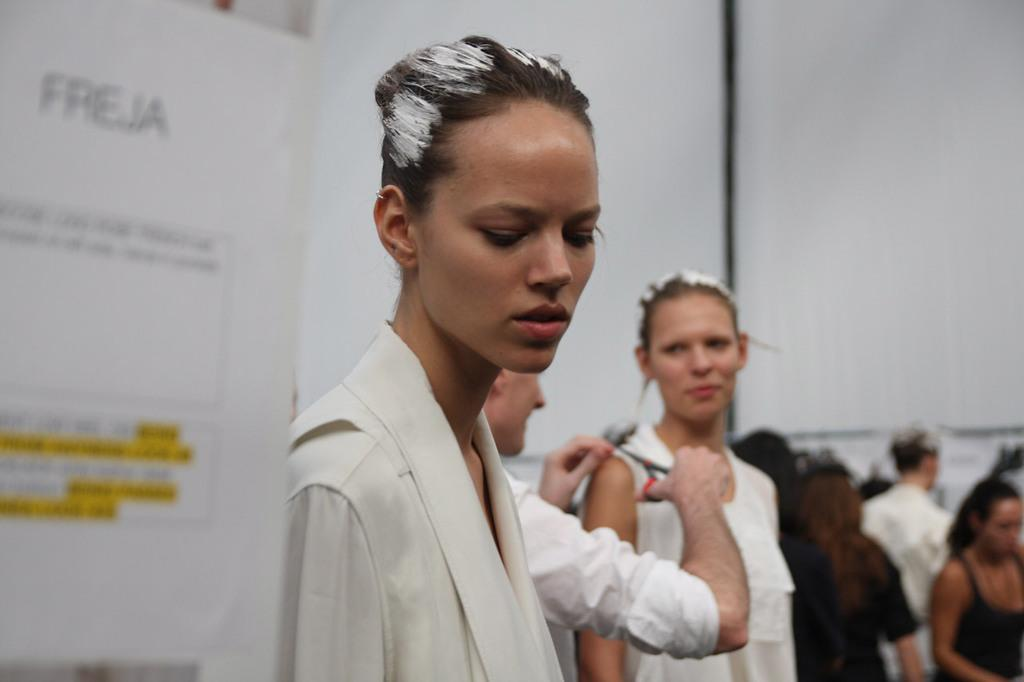What is the main subject of the image? The main subject of the image is a group of people. What colors are the people wearing? The people are wearing white and black color dresses. What can be seen to the left of the image? There is a banner to the left of the image. What color is the background of the image? The background of the image is white. Are there any swings visible in the image? No, there are no swings present in the image. What type of umbrella is being used by the people in the image? There is no umbrella visible in the image. 